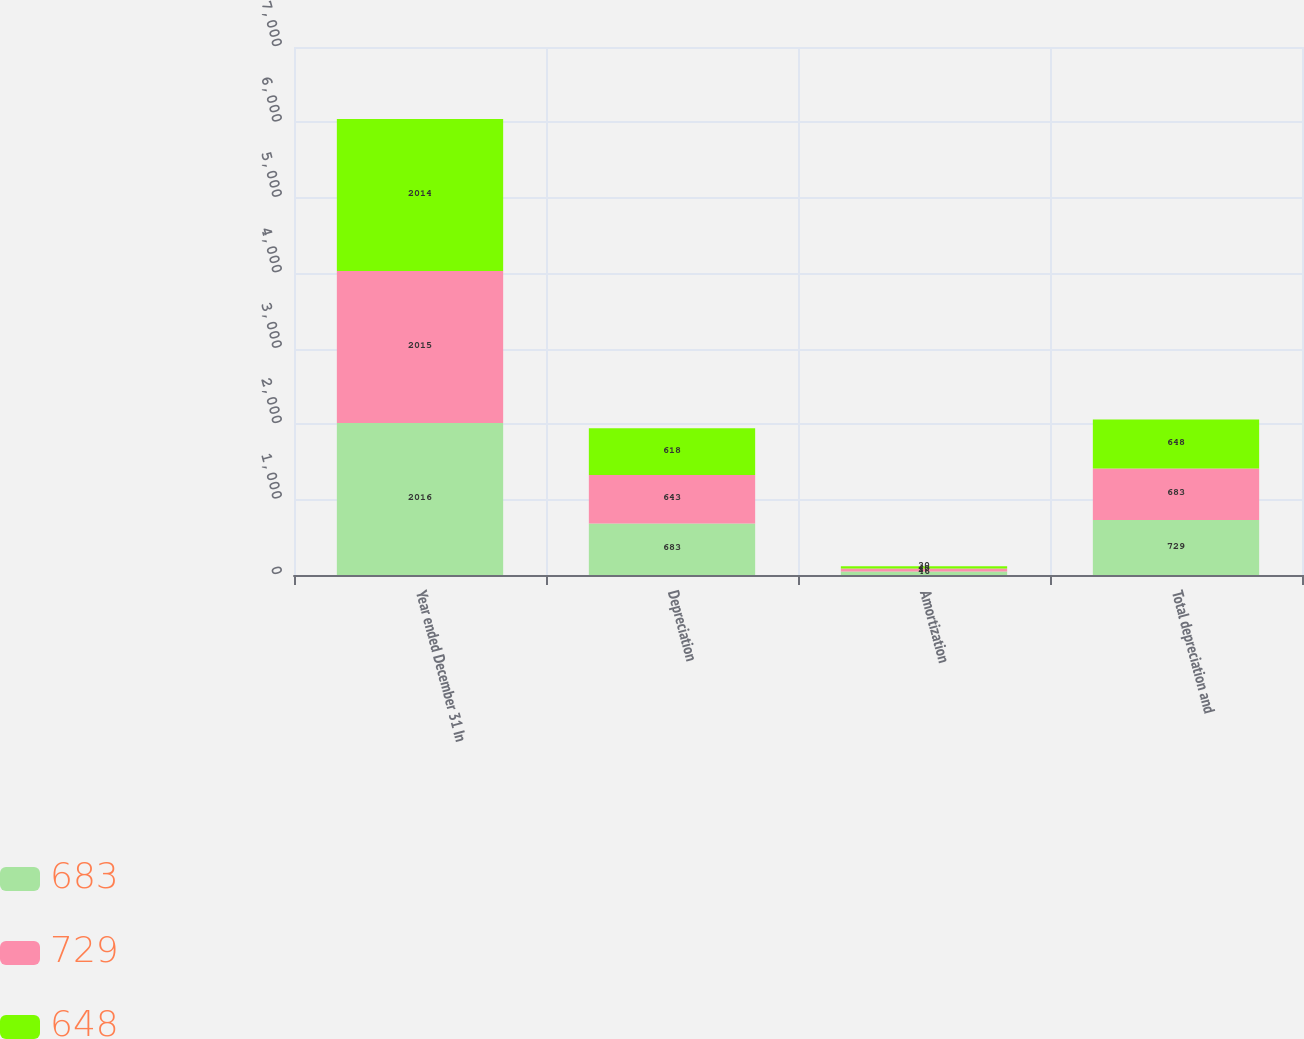<chart> <loc_0><loc_0><loc_500><loc_500><stacked_bar_chart><ecel><fcel>Year ended December 31 In<fcel>Depreciation<fcel>Amortization<fcel>Total depreciation and<nl><fcel>683<fcel>2016<fcel>683<fcel>46<fcel>729<nl><fcel>729<fcel>2015<fcel>643<fcel>40<fcel>683<nl><fcel>648<fcel>2014<fcel>618<fcel>30<fcel>648<nl></chart> 